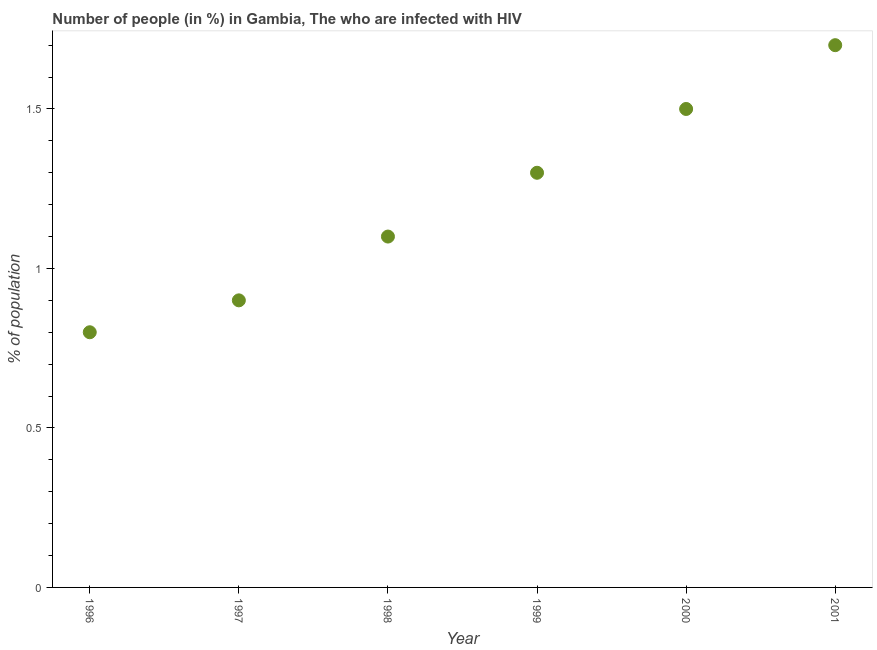Across all years, what is the maximum number of people infected with hiv?
Provide a succinct answer. 1.7. Across all years, what is the minimum number of people infected with hiv?
Offer a terse response. 0.8. What is the sum of the number of people infected with hiv?
Your answer should be compact. 7.3. What is the difference between the number of people infected with hiv in 1998 and 1999?
Keep it short and to the point. -0.2. What is the average number of people infected with hiv per year?
Offer a very short reply. 1.22. What is the median number of people infected with hiv?
Give a very brief answer. 1.2. In how many years, is the number of people infected with hiv greater than 0.5 %?
Provide a succinct answer. 6. Do a majority of the years between 2001 and 1998 (inclusive) have number of people infected with hiv greater than 1.3 %?
Give a very brief answer. Yes. What is the ratio of the number of people infected with hiv in 1998 to that in 2001?
Provide a succinct answer. 0.65. What is the difference between the highest and the second highest number of people infected with hiv?
Provide a short and direct response. 0.2. Is the sum of the number of people infected with hiv in 1996 and 1999 greater than the maximum number of people infected with hiv across all years?
Make the answer very short. Yes. What is the difference between the highest and the lowest number of people infected with hiv?
Give a very brief answer. 0.9. Does the number of people infected with hiv monotonically increase over the years?
Ensure brevity in your answer.  Yes. How many years are there in the graph?
Provide a succinct answer. 6. Are the values on the major ticks of Y-axis written in scientific E-notation?
Provide a short and direct response. No. Does the graph contain grids?
Provide a short and direct response. No. What is the title of the graph?
Offer a very short reply. Number of people (in %) in Gambia, The who are infected with HIV. What is the label or title of the Y-axis?
Your answer should be very brief. % of population. What is the % of population in 1996?
Offer a terse response. 0.8. What is the % of population in 1997?
Offer a terse response. 0.9. What is the % of population in 2001?
Offer a very short reply. 1.7. What is the difference between the % of population in 1996 and 2000?
Give a very brief answer. -0.7. What is the difference between the % of population in 1996 and 2001?
Your answer should be compact. -0.9. What is the difference between the % of population in 1998 and 2001?
Provide a succinct answer. -0.6. What is the difference between the % of population in 1999 and 2000?
Give a very brief answer. -0.2. What is the difference between the % of population in 2000 and 2001?
Provide a short and direct response. -0.2. What is the ratio of the % of population in 1996 to that in 1997?
Your response must be concise. 0.89. What is the ratio of the % of population in 1996 to that in 1998?
Make the answer very short. 0.73. What is the ratio of the % of population in 1996 to that in 1999?
Offer a very short reply. 0.61. What is the ratio of the % of population in 1996 to that in 2000?
Offer a very short reply. 0.53. What is the ratio of the % of population in 1996 to that in 2001?
Give a very brief answer. 0.47. What is the ratio of the % of population in 1997 to that in 1998?
Your response must be concise. 0.82. What is the ratio of the % of population in 1997 to that in 1999?
Offer a terse response. 0.69. What is the ratio of the % of population in 1997 to that in 2001?
Offer a very short reply. 0.53. What is the ratio of the % of population in 1998 to that in 1999?
Provide a succinct answer. 0.85. What is the ratio of the % of population in 1998 to that in 2000?
Your answer should be compact. 0.73. What is the ratio of the % of population in 1998 to that in 2001?
Provide a short and direct response. 0.65. What is the ratio of the % of population in 1999 to that in 2000?
Give a very brief answer. 0.87. What is the ratio of the % of population in 1999 to that in 2001?
Your answer should be compact. 0.77. What is the ratio of the % of population in 2000 to that in 2001?
Keep it short and to the point. 0.88. 